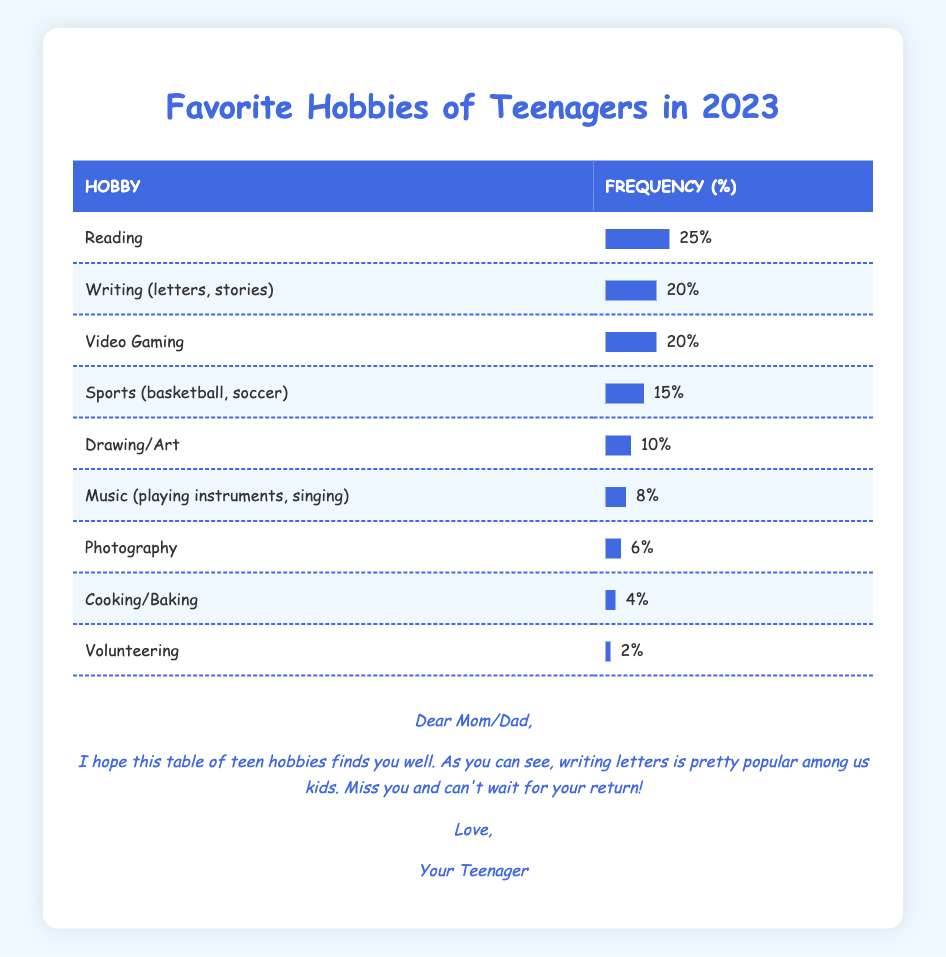What is the most popular hobby among teenagers in 2023? The table shows the frequency of each hobby. Reading has the highest frequency of 25%, making it the most popular hobby.
Answer: Reading How many teenagers enjoy drawing/art? The frequency of Drawing/Art is listed as 10%, indicating that 10% of teenagers enjoy this hobby.
Answer: 10% Do more teenagers prefer video gaming or music? Video Gaming has a frequency of 20% while Music has a frequency of 8%. Since 20% is greater than 8%, more teenagers prefer video gaming than music.
Answer: Yes What is the total percentage of teenagers who enjoy sports and drawing/art combined? The frequency for Sports is 15% and for Drawing/Art is 10%. Adding these together gives 15% + 10% = 25%.
Answer: 25% Is cooking/baking a more popular hobby among teenagers compared to volunteering? Cooking/Baking has a frequency of 4% while Volunteering has a frequency of 2%. Since 4% is greater than 2%, cooking/baking is more popular.
Answer: Yes What is the difference in frequency between the most popular and least popular hobbies? The most popular hobby (Reading) has a frequency of 25% and the least popular (Volunteering) has a frequency of 2%. The difference is 25% - 2% = 23%.
Answer: 23% How many hobbies have a frequency of 10% or higher? The hobbies with 10% or higher frequencies are Reading, Writing, Video Gaming, and Sports. That's a total of 4 hobbies.
Answer: 4 What percentage of teenagers enjoy hobbies that involve creativity, like Drawing, Music, and Writing? The frequencies for Drawing, Music, and Writing are 10%, 8%, and 20%, respectively. Adding these gives 10% + 8% + 20% = 38%.
Answer: 38% What is the average frequency of the three least popular hobbies? The three least popular hobbies are Photography (6%), Cooking/Baking (4%), and Volunteering (2%). Adding these gives 6% + 4% + 2% = 12%. Dividing by 3 gives an average of 12% / 3 = 4%.
Answer: 4% 